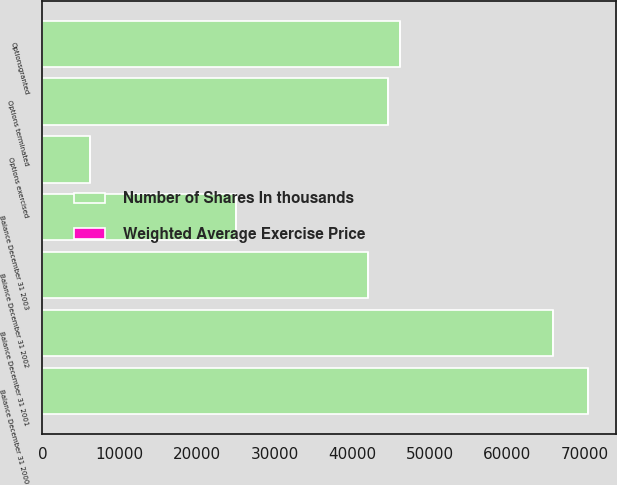Convert chart to OTSL. <chart><loc_0><loc_0><loc_500><loc_500><stacked_bar_chart><ecel><fcel>Balance December 31 2000<fcel>Optionsgranted<fcel>Options terminated<fcel>Options exercised<fcel>Balance December 31 2001<fcel>Balance December 31 2002<fcel>Balance December 31 2003<nl><fcel>Number of Shares In thousands<fcel>70438<fcel>46209<fcel>44608<fcel>6089<fcel>65950<fcel>42005<fcel>24961<nl><fcel>Weighted Average Exercise Price<fcel>32.17<fcel>9.53<fcel>43.91<fcel>2.73<fcel>10.65<fcel>11.91<fcel>12.46<nl></chart> 